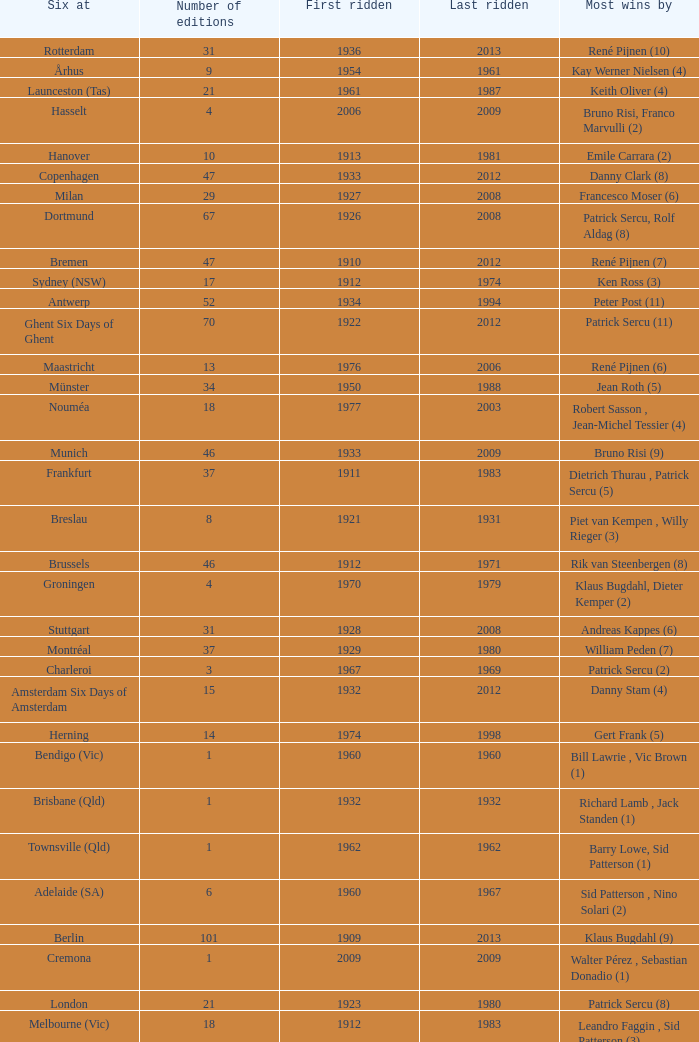How many editions have a most wins value of Franco Marvulli (4)? 1.0. 